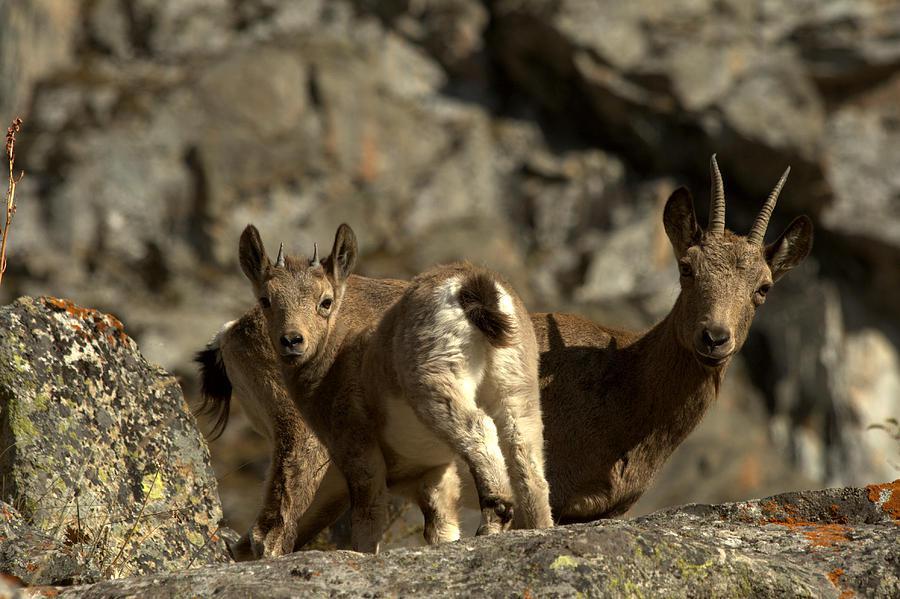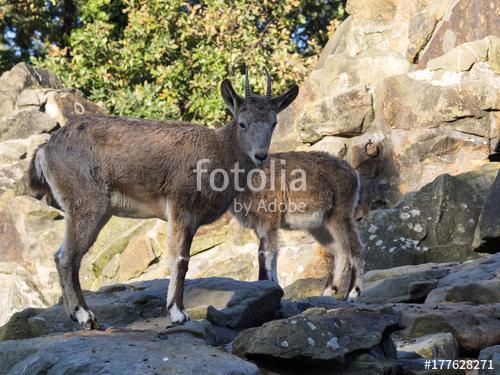The first image is the image on the left, the second image is the image on the right. Considering the images on both sides, is "Four or fewer goats are visible." valid? Answer yes or no. Yes. The first image is the image on the left, the second image is the image on the right. For the images shown, is this caption "The left image shows at least one goat with very long horns on its head." true? Answer yes or no. No. 